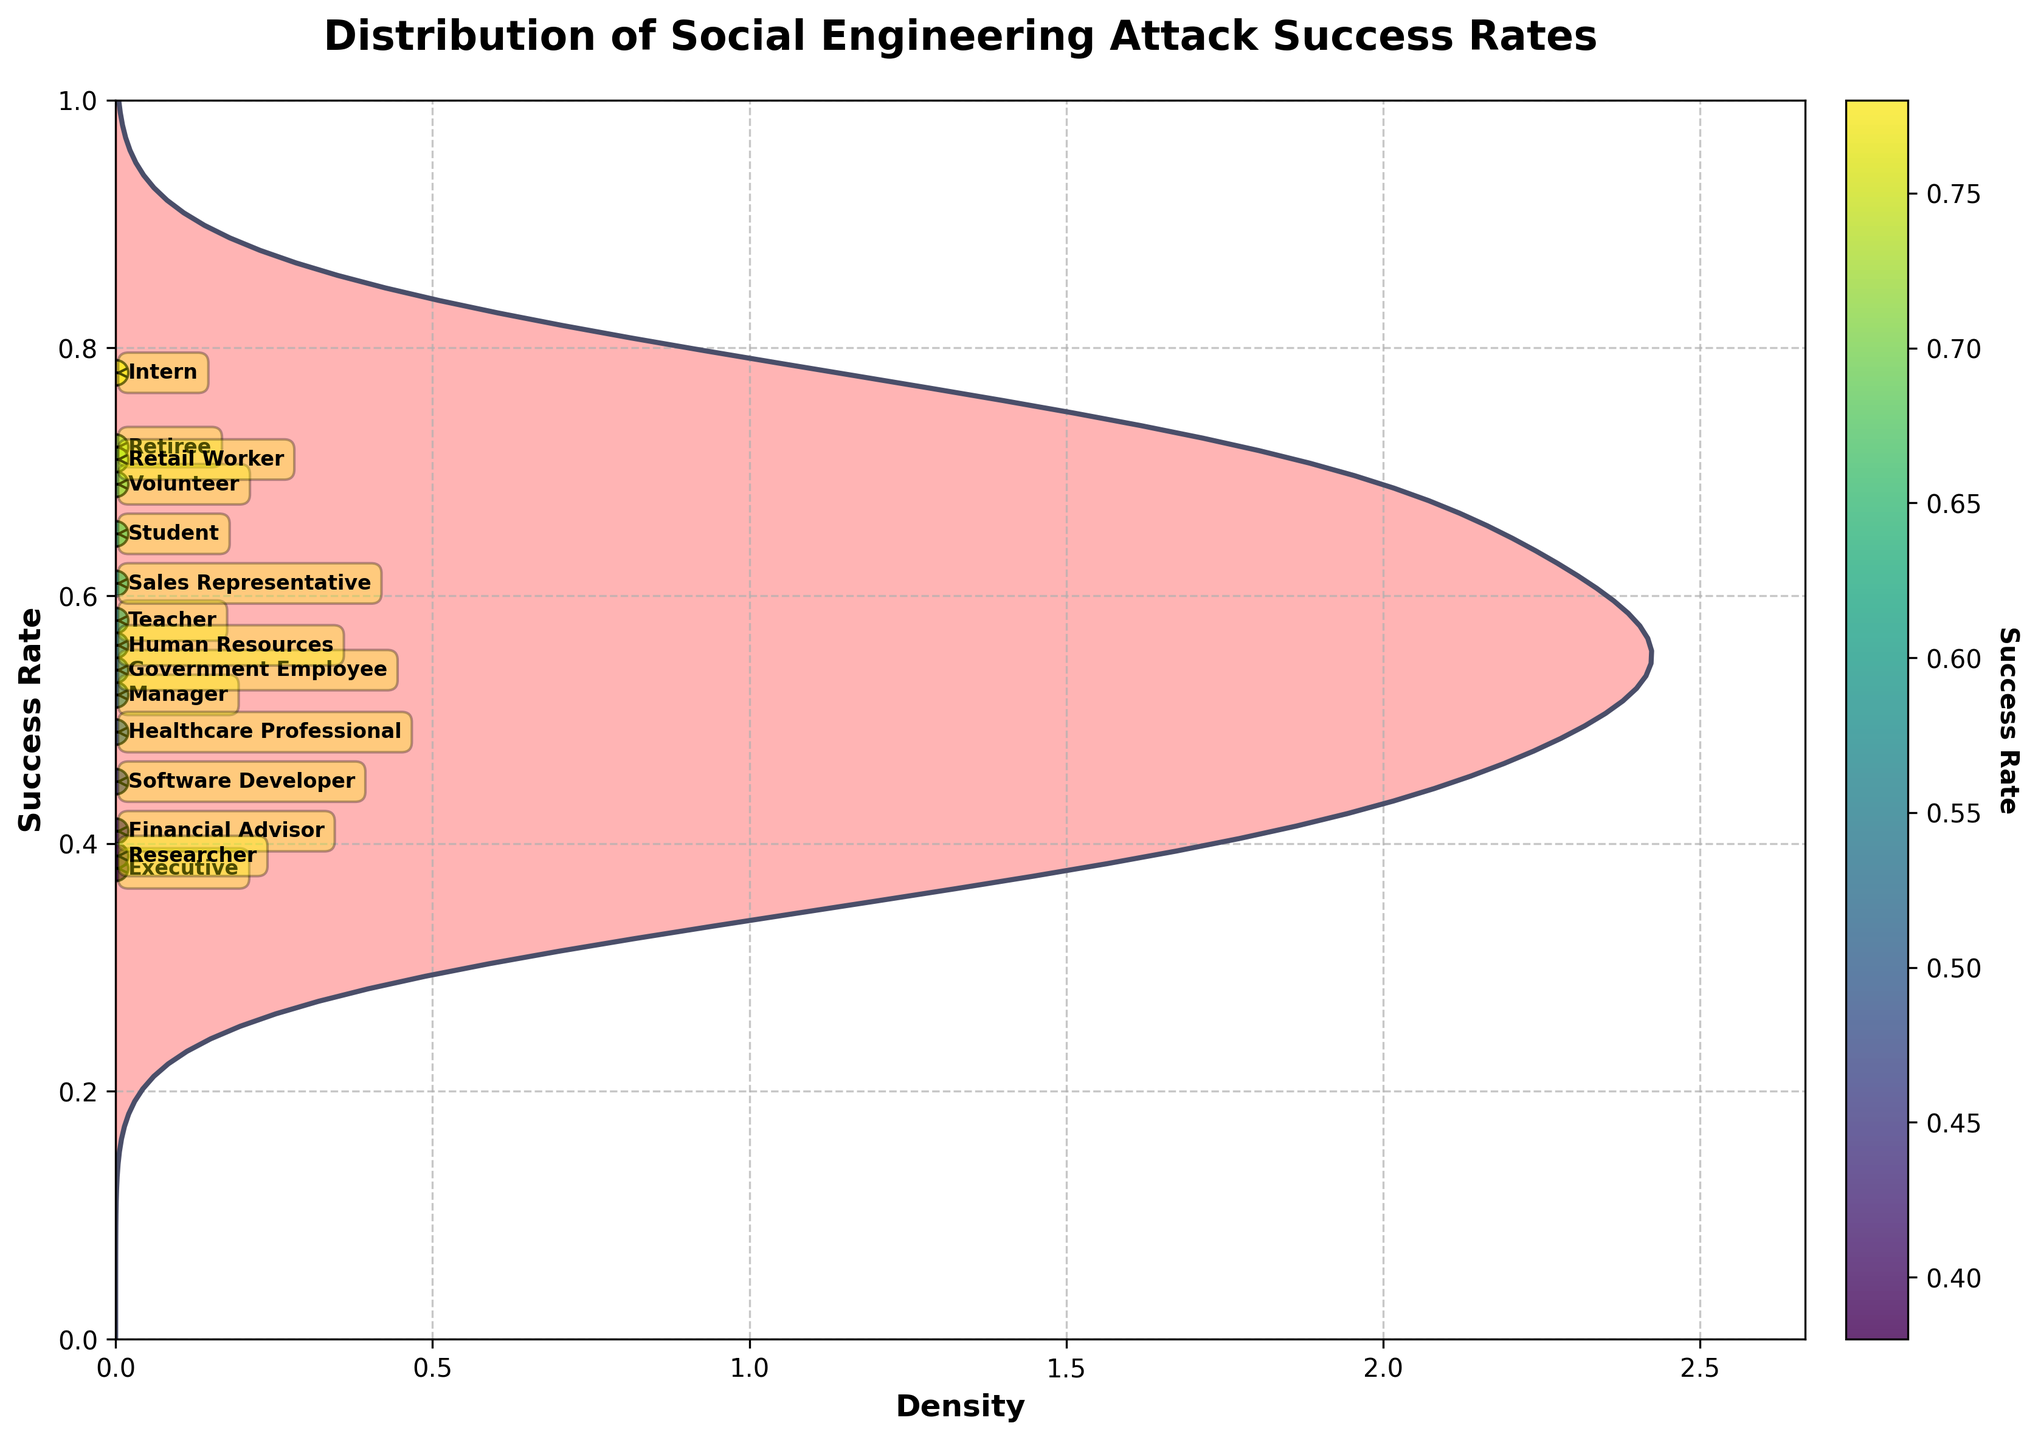What's the title of the plot? The title is prominently displayed at the top of the plot area. It reads "Distribution of Social Engineering Attack Success Rates."
Answer: Distribution of Social Engineering Attack Success Rates Which age group has the highest success rate in social engineering attacks? By observing the horizontal positions of the annotated points and their corresponding success rates, the Retiree in the age group 65+ has the highest recorded success rate of 0.72.
Answer: 65+ How many occupations are depicted in the plot? Each point in the scatter plot represents an occupation. By counting the unique annotated points, we can determine there are 14 occupations displayed.
Answer: 14 Which occupation has the lowest success rate, and what is that rate? By identifying the lowest position in the scatter plot and checking the annotation, the Researcher occupation has the lowest success rate at approximately 0.39.
Answer: Researcher, 0.39 What's the total number of data points in the plot? Each entry in the dataset corresponds to a data point in the scatter plot. By counting all the points, we conclude there are 12 data points in the plot.
Answer: 12 Which age group occupies the highest density area in the plot? To determine this, we check the density curve where it is the widest and most filled. The age group 18-25 occupies a predominant position with a high success rate clustering around 0.7.
Answer: 18-25 What range of success rates does the horizontal density plot cover? By observing the vertical span of the density plot, the success rates range from the lowest point of around 0.38 to the highest point of approximately 0.78.
Answer: 0.38 to 0.78 Out of the occupations, which have a success rate greater than 0.50? Checking the positions of annotated points above the 0.5 mark in the scatter plot, the occupations include Student, Intern, Teacher, Sales Representative, Human Resources, and Volunteer.
Answer: Student, Intern, Teacher, Sales Representative, Human Resources, Volunteer Which age group and occupation combination has the second highest success rate? The second highest point on the scatter plot indicates the Intern occupation in the 18-25 age group with a success rate of around 0.78.
Answer: 18-25, Intern What does the x-axis represent in the plot? The x-axis in the plot quantifies the density of success rates, as indicated by the label “Density.”
Answer: Density 